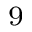Convert formula to latex. <formula><loc_0><loc_0><loc_500><loc_500>^ { 9 }</formula> 